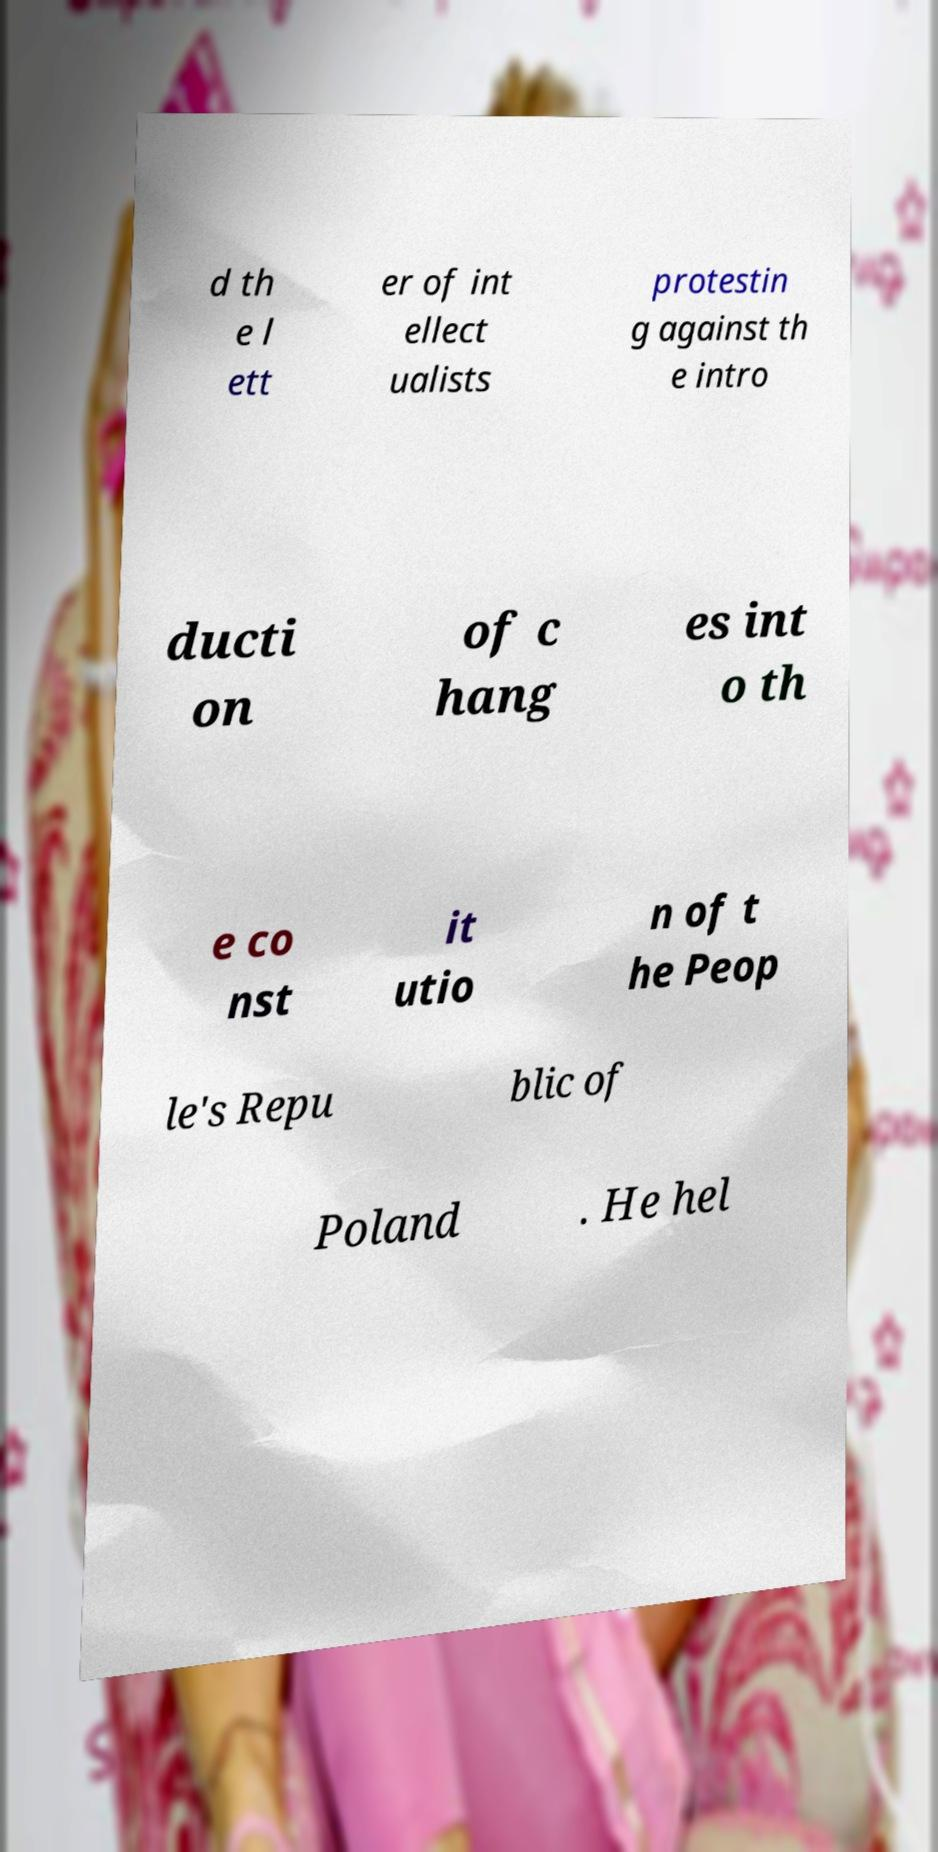I need the written content from this picture converted into text. Can you do that? d th e l ett er of int ellect ualists protestin g against th e intro ducti on of c hang es int o th e co nst it utio n of t he Peop le's Repu blic of Poland . He hel 